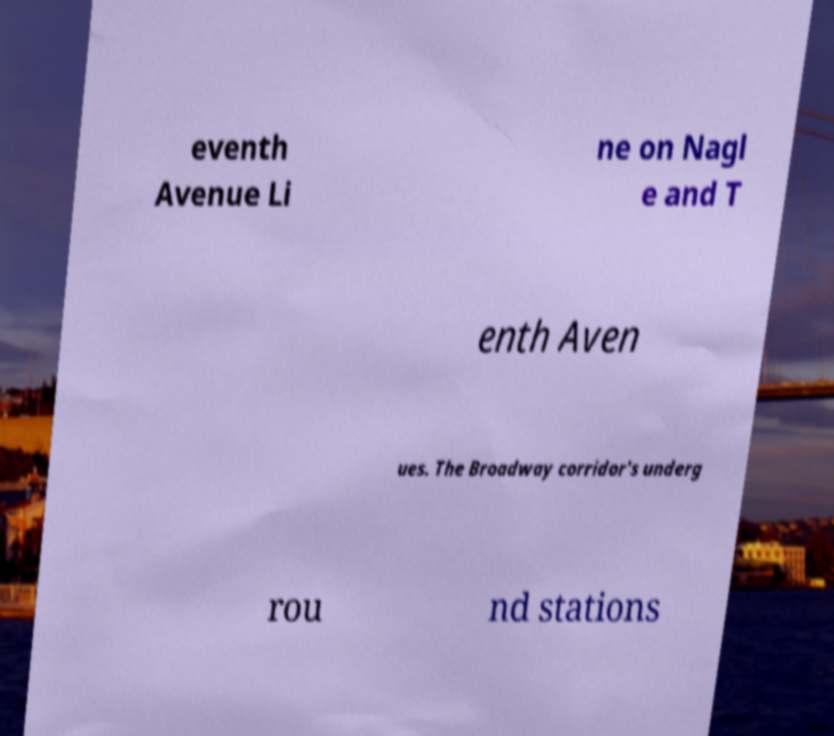What messages or text are displayed in this image? I need them in a readable, typed format. eventh Avenue Li ne on Nagl e and T enth Aven ues. The Broadway corridor's underg rou nd stations 